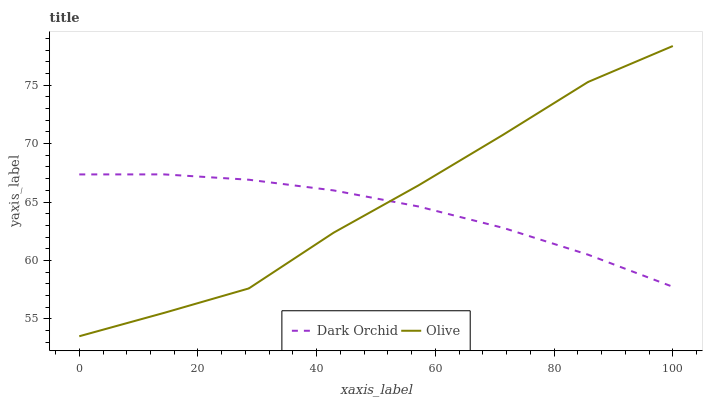Does Dark Orchid have the minimum area under the curve?
Answer yes or no. Yes. Does Olive have the maximum area under the curve?
Answer yes or no. Yes. Does Dark Orchid have the maximum area under the curve?
Answer yes or no. No. Is Dark Orchid the smoothest?
Answer yes or no. Yes. Is Olive the roughest?
Answer yes or no. Yes. Is Dark Orchid the roughest?
Answer yes or no. No. Does Olive have the lowest value?
Answer yes or no. Yes. Does Dark Orchid have the lowest value?
Answer yes or no. No. Does Olive have the highest value?
Answer yes or no. Yes. Does Dark Orchid have the highest value?
Answer yes or no. No. Does Dark Orchid intersect Olive?
Answer yes or no. Yes. Is Dark Orchid less than Olive?
Answer yes or no. No. Is Dark Orchid greater than Olive?
Answer yes or no. No. 